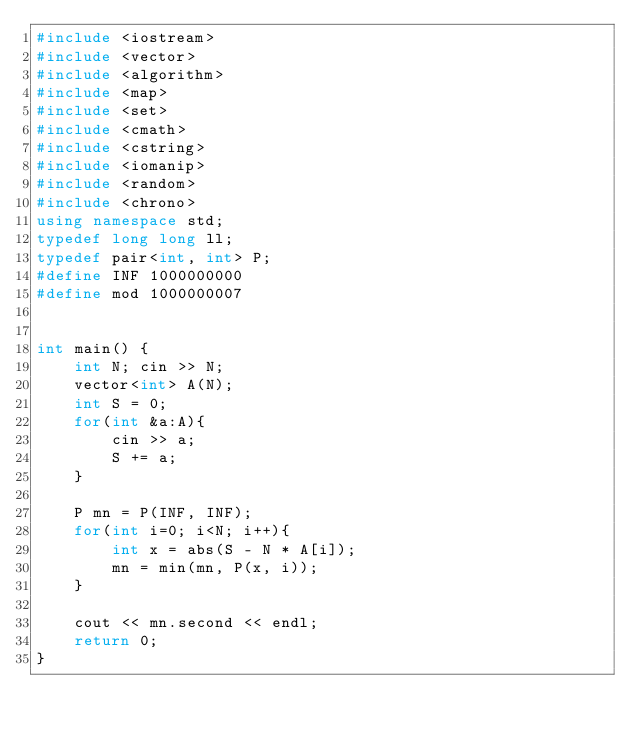<code> <loc_0><loc_0><loc_500><loc_500><_C++_>#include <iostream>
#include <vector>
#include <algorithm>
#include <map>
#include <set>
#include <cmath>
#include <cstring>
#include <iomanip>
#include <random>
#include <chrono>
using namespace std;
typedef long long ll;
typedef pair<int, int> P;
#define INF 1000000000
#define mod 1000000007


int main() {
    int N; cin >> N;
    vector<int> A(N);
    int S = 0;
    for(int &a:A){
        cin >> a;
        S += a;
    }
    
    P mn = P(INF, INF);
    for(int i=0; i<N; i++){
        int x = abs(S - N * A[i]);
        mn = min(mn, P(x, i));
    }
    
    cout << mn.second << endl;
    return 0;
}



</code> 